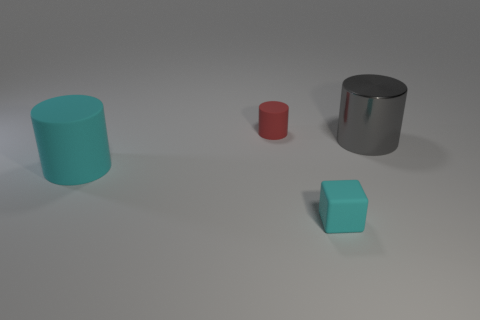Subtract all cyan cylinders. How many cylinders are left? 2 Add 1 green metal balls. How many objects exist? 5 Subtract all gray cylinders. How many cylinders are left? 2 Add 2 red things. How many red things exist? 3 Subtract 0 gray spheres. How many objects are left? 4 Subtract all cylinders. How many objects are left? 1 Subtract 3 cylinders. How many cylinders are left? 0 Subtract all gray cylinders. Subtract all red cubes. How many cylinders are left? 2 Subtract all large rubber cylinders. Subtract all cyan matte blocks. How many objects are left? 2 Add 4 large metallic things. How many large metallic things are left? 5 